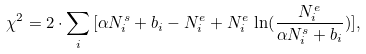<formula> <loc_0><loc_0><loc_500><loc_500>\chi ^ { 2 } = 2 \cdot \sum _ { i } \, [ \alpha N _ { i } ^ { s } + b _ { i } - N _ { i } ^ { e } + N _ { i } ^ { e } \, \ln ( \frac { N _ { i } ^ { e } } { \alpha N _ { i } ^ { s } + b _ { i } } ) ] ,</formula> 